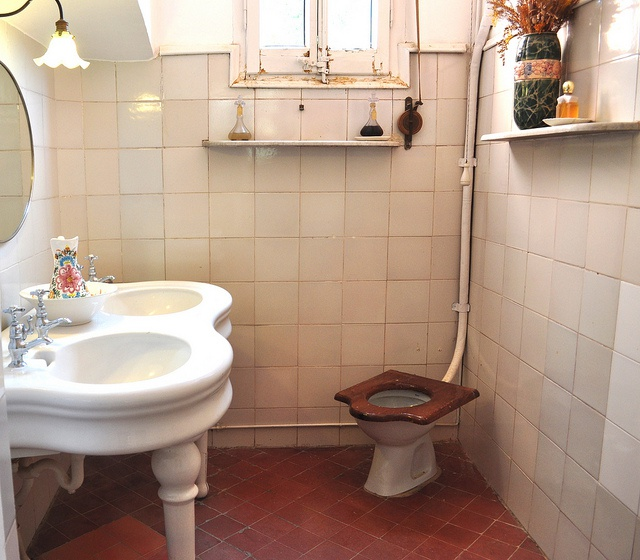Describe the objects in this image and their specific colors. I can see sink in lightyellow, white, darkgray, and gray tones, toilet in lightyellow, maroon, gray, brown, and black tones, vase in lightyellow, black, and gray tones, and vase in lightyellow, lightgray, lightpink, darkgray, and brown tones in this image. 